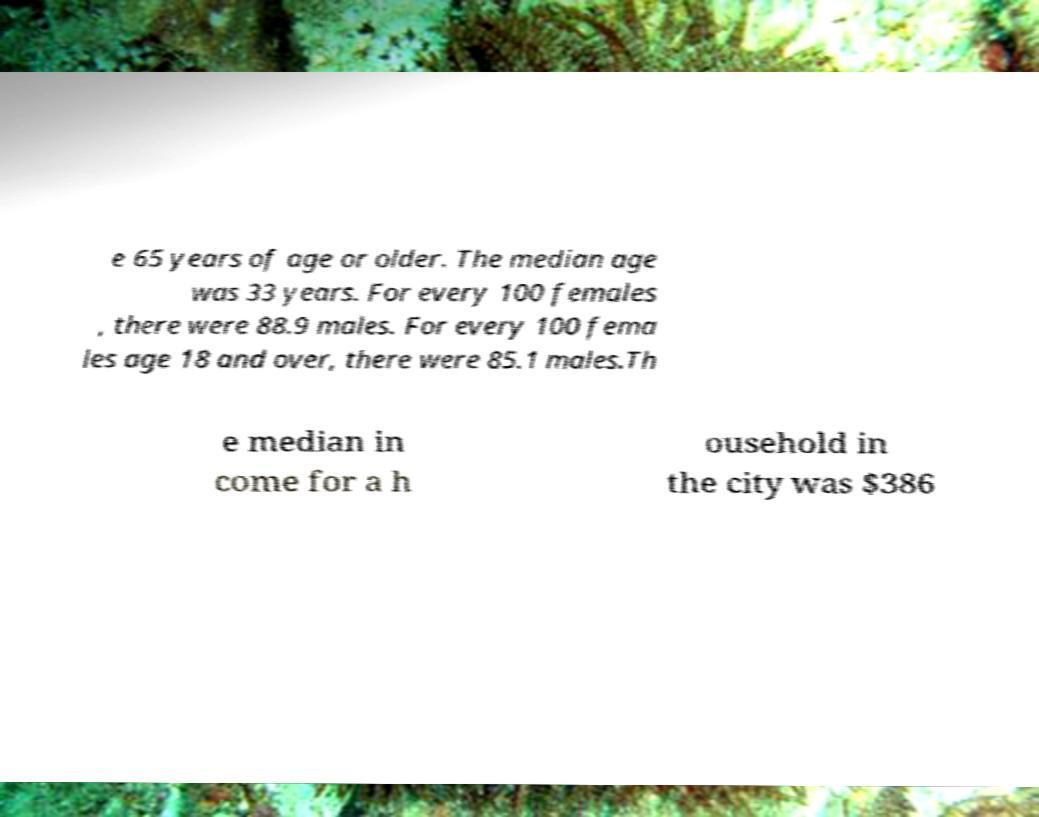I need the written content from this picture converted into text. Can you do that? e 65 years of age or older. The median age was 33 years. For every 100 females , there were 88.9 males. For every 100 fema les age 18 and over, there were 85.1 males.Th e median in come for a h ousehold in the city was $386 